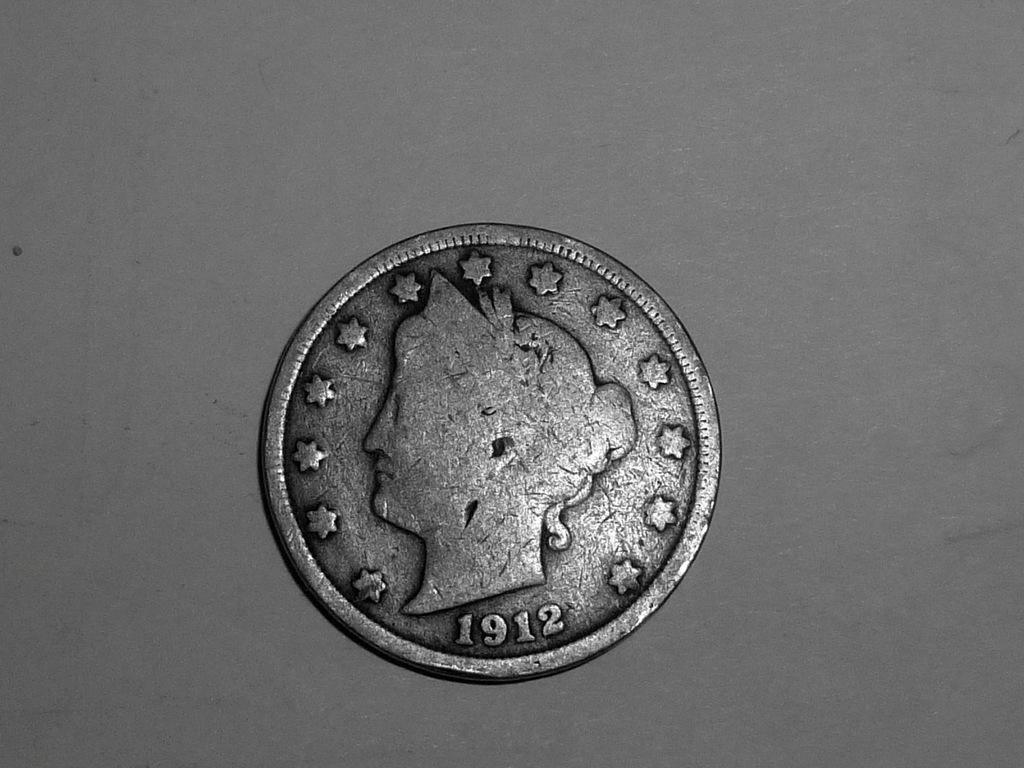Provide a one-sentence caption for the provided image. An older silver coin was minted in 1912. 